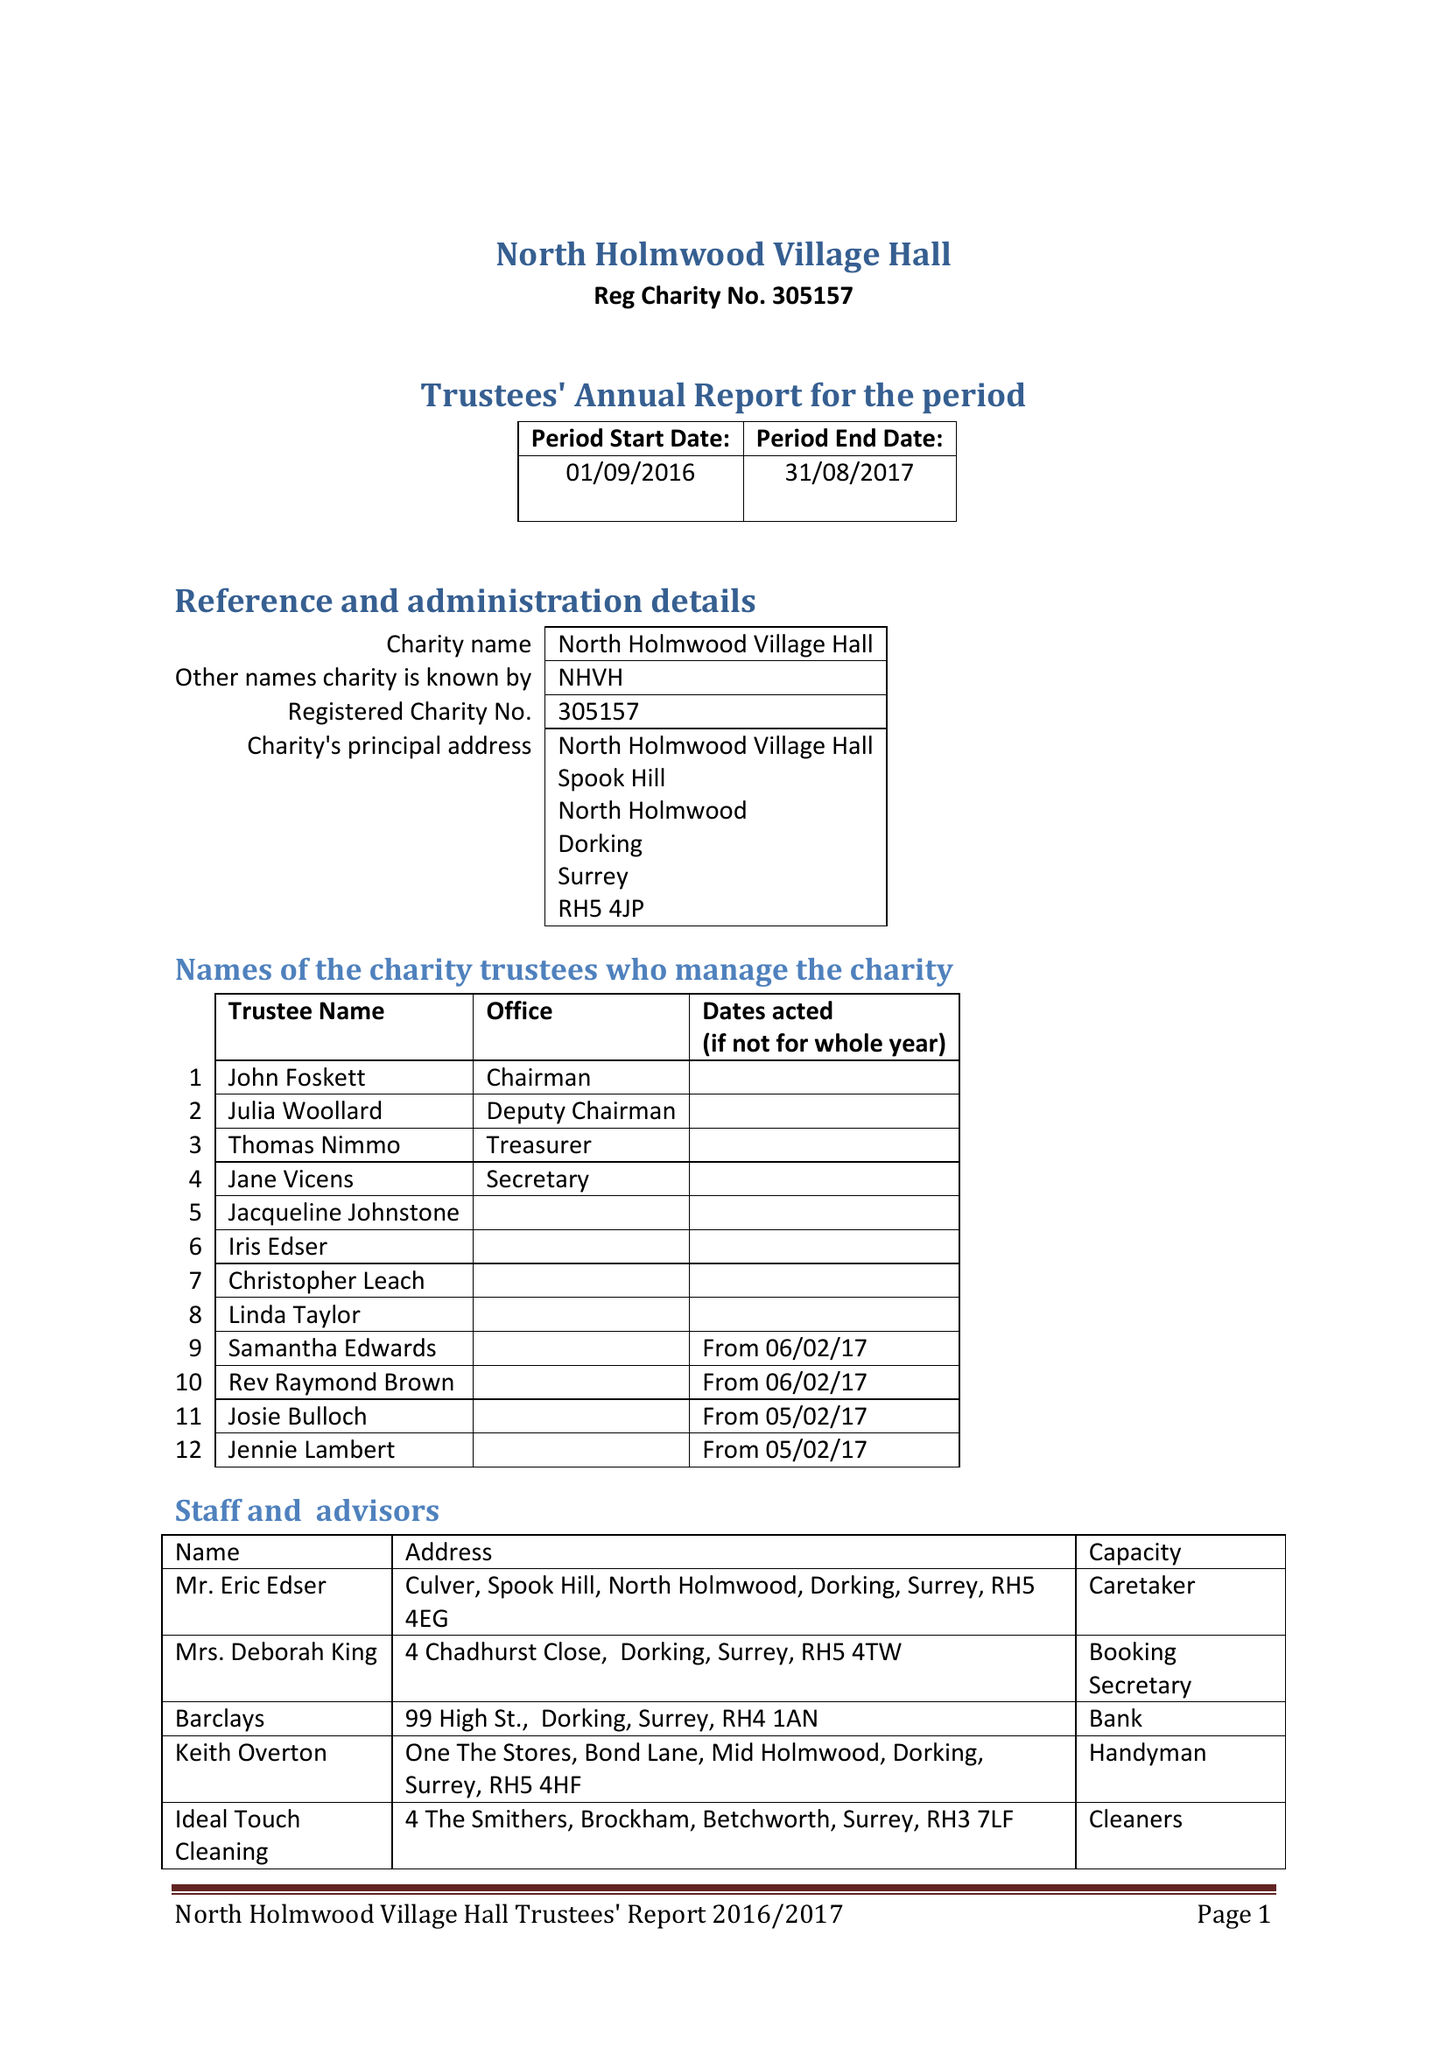What is the value for the income_annually_in_british_pounds?
Answer the question using a single word or phrase. 34842.00 